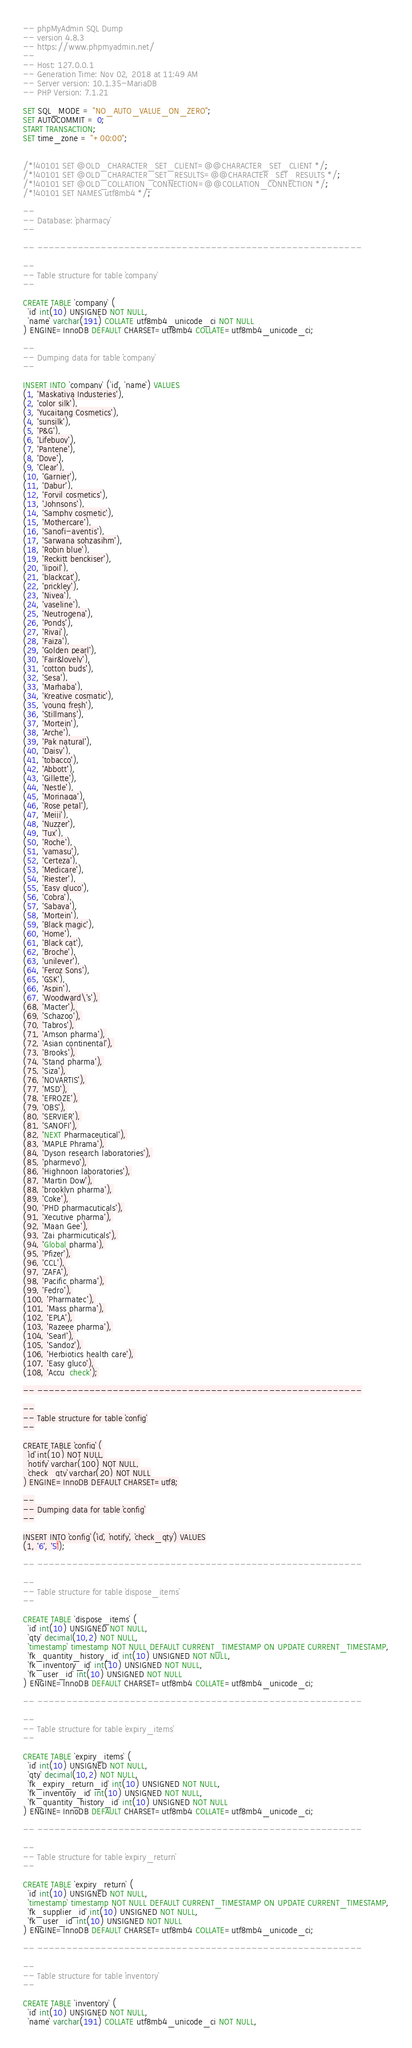<code> <loc_0><loc_0><loc_500><loc_500><_SQL_>-- phpMyAdmin SQL Dump
-- version 4.8.3
-- https://www.phpmyadmin.net/
--
-- Host: 127.0.0.1
-- Generation Time: Nov 02, 2018 at 11:49 AM
-- Server version: 10.1.35-MariaDB
-- PHP Version: 7.1.21

SET SQL_MODE = "NO_AUTO_VALUE_ON_ZERO";
SET AUTOCOMMIT = 0;
START TRANSACTION;
SET time_zone = "+00:00";


/*!40101 SET @OLD_CHARACTER_SET_CLIENT=@@CHARACTER_SET_CLIENT */;
/*!40101 SET @OLD_CHARACTER_SET_RESULTS=@@CHARACTER_SET_RESULTS */;
/*!40101 SET @OLD_COLLATION_CONNECTION=@@COLLATION_CONNECTION */;
/*!40101 SET NAMES utf8mb4 */;

--
-- Database: `pharmacy`
--

-- --------------------------------------------------------

--
-- Table structure for table `company`
--

CREATE TABLE `company` (
  `id` int(10) UNSIGNED NOT NULL,
  `name` varchar(191) COLLATE utf8mb4_unicode_ci NOT NULL
) ENGINE=InnoDB DEFAULT CHARSET=utf8mb4 COLLATE=utf8mb4_unicode_ci;

--
-- Dumping data for table `company`
--

INSERT INTO `company` (`id`, `name`) VALUES
(1, 'Maskatiya Industeries'),
(2, 'color silk'),
(3, 'Yucaitang Cosmetics'),
(4, 'sunsilk'),
(5, 'P&G'),
(6, 'Lifebuoy'),
(7, 'Pantene'),
(8, 'Dove'),
(9, 'Clear'),
(10, 'Garnier'),
(11, 'Dabur'),
(12, 'Forvil cosmetics'),
(13, 'Johnsons'),
(14, 'Samphy cosmetic'),
(15, 'Mothercare'),
(16, 'Sanofi-aventis'),
(17, 'Sarwana sohzasihm'),
(18, 'Robin blue'),
(19, 'Reckitt benckiser'),
(20, 'lipoil'),
(21, 'blackcat'),
(22, 'prickley'),
(23, 'Nivea'),
(24, 'vaseline'),
(25, 'Neutrogena'),
(26, 'Ponds'),
(27, 'Rivaj'),
(28, 'Faiza'),
(29, 'Golden pearl'),
(30, 'Fair&lovely'),
(31, 'cotton buds'),
(32, 'Sesa'),
(33, 'Marhaba'),
(34, 'Kreative cosmatic'),
(35, 'young fresh'),
(36, 'Stillmans'),
(37, 'Mortein'),
(38, 'Arche'),
(39, 'Pak natural'),
(40, 'Daisy'),
(41, 'tobacco'),
(42, 'Abbott'),
(43, 'Gillette'),
(44, 'Nestle'),
(45, 'Morinaga'),
(46, 'Rose petal'),
(47, 'Meiji'),
(48, 'Nuzzer'),
(49, 'Tux'),
(50, 'Roche'),
(51, 'yamasu'),
(52, 'Certeza'),
(53, 'Medicare'),
(54, 'Riester'),
(55, 'Easy gluco'),
(56, 'Cobra'),
(57, 'Sabaya'),
(58, 'Mortein'),
(59, 'Black magic'),
(60, 'Home'),
(61, 'Black cat'),
(62, 'Broche'),
(63, 'unilever'),
(64, 'Feroz Sons'),
(65, 'GSK'),
(66, 'Aspin'),
(67, 'Woodward\'s'),
(68, 'Macter'),
(69, 'Schazoo'),
(70, 'Tabros'),
(71, 'Amson pharma'),
(72, 'Asian continental'),
(73, 'Brooks'),
(74, 'Stand pharma'),
(75, 'Siza'),
(76, 'NOVARTIS'),
(77, 'MSD'),
(78, 'EFROZE'),
(79, 'OBS'),
(80, 'SERVIER'),
(81, 'SANOFI'),
(82, 'NEXT Pharmaceutical'),
(83, 'MAPLE Phrama'),
(84, 'Dyson research laboratories'),
(85, 'pharmevo'),
(86, 'Highnoon laboratories'),
(87, 'Martin Dow'),
(88, 'brooklyn pharma'),
(89, 'Coke'),
(90, 'PHD pharmacuticals'),
(91, 'Xecutive pharma'),
(92, 'Maan Gee'),
(93, 'Zai pharmicuticals'),
(94, 'Global pharma'),
(95, 'Pfizer'),
(96, 'CCL'),
(97, 'ZAFA'),
(98, 'Pacific pharma'),
(99, 'Fedro'),
(100, 'Pharmatec'),
(101, 'Mass pharma'),
(102, 'EPLA'),
(103, 'Razeee pharma'),
(104, 'Searl'),
(105, 'Sandoz'),
(106, 'Herbiotics health care'),
(107, 'Easy gluco'),
(108, 'Accu  check');

-- --------------------------------------------------------

--
-- Table structure for table `config`
--

CREATE TABLE `config` (
  `id` int(10) NOT NULL,
  `notify` varchar(100) NOT NULL,
  `check_qty` varchar(20) NOT NULL
) ENGINE=InnoDB DEFAULT CHARSET=utf8;

--
-- Dumping data for table `config`
--

INSERT INTO `config` (`id`, `notify`, `check_qty`) VALUES
(1, '6', '5');

-- --------------------------------------------------------

--
-- Table structure for table `dispose_items`
--

CREATE TABLE `dispose_items` (
  `id` int(10) UNSIGNED NOT NULL,
  `qty` decimal(10,2) NOT NULL,
  `timestamp` timestamp NOT NULL DEFAULT CURRENT_TIMESTAMP ON UPDATE CURRENT_TIMESTAMP,
  `fk_quantity_history_id` int(10) UNSIGNED NOT NULL,
  `fk_inventory_id` int(10) UNSIGNED NOT NULL,
  `fk_user_id` int(10) UNSIGNED NOT NULL
) ENGINE=InnoDB DEFAULT CHARSET=utf8mb4 COLLATE=utf8mb4_unicode_ci;

-- --------------------------------------------------------

--
-- Table structure for table `expiry_items`
--

CREATE TABLE `expiry_items` (
  `id` int(10) UNSIGNED NOT NULL,
  `qty` decimal(10,2) NOT NULL,
  `fk_expiry_return_id` int(10) UNSIGNED NOT NULL,
  `fk_inventory_id` int(10) UNSIGNED NOT NULL,
  `fk_quantity_history_id` int(10) UNSIGNED NOT NULL
) ENGINE=InnoDB DEFAULT CHARSET=utf8mb4 COLLATE=utf8mb4_unicode_ci;

-- --------------------------------------------------------

--
-- Table structure for table `expiry_return`
--

CREATE TABLE `expiry_return` (
  `id` int(10) UNSIGNED NOT NULL,
  `timestamp` timestamp NOT NULL DEFAULT CURRENT_TIMESTAMP ON UPDATE CURRENT_TIMESTAMP,
  `fk_supplier_id` int(10) UNSIGNED NOT NULL,
  `fk_user_id` int(10) UNSIGNED NOT NULL
) ENGINE=InnoDB DEFAULT CHARSET=utf8mb4 COLLATE=utf8mb4_unicode_ci;

-- --------------------------------------------------------

--
-- Table structure for table `inventory`
--

CREATE TABLE `inventory` (
  `id` int(10) UNSIGNED NOT NULL,
  `name` varchar(191) COLLATE utf8mb4_unicode_ci NOT NULL,</code> 